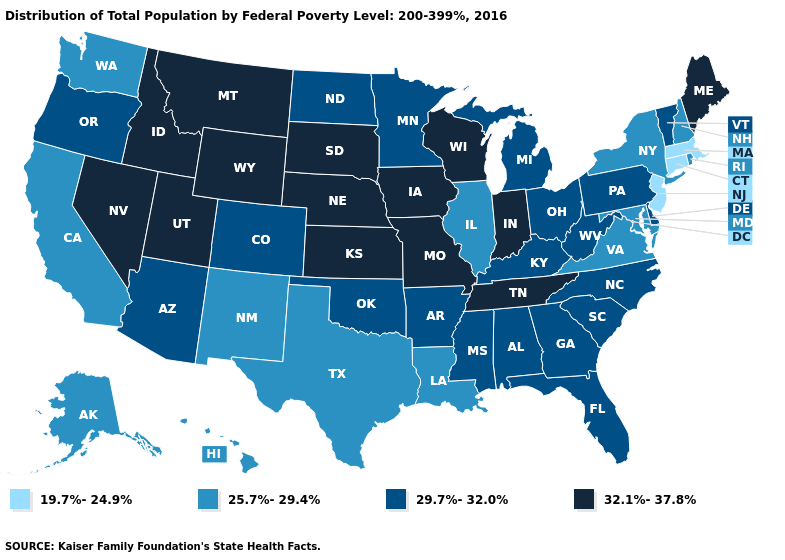Name the states that have a value in the range 29.7%-32.0%?
Be succinct. Alabama, Arizona, Arkansas, Colorado, Delaware, Florida, Georgia, Kentucky, Michigan, Minnesota, Mississippi, North Carolina, North Dakota, Ohio, Oklahoma, Oregon, Pennsylvania, South Carolina, Vermont, West Virginia. What is the value of Louisiana?
Keep it brief. 25.7%-29.4%. Name the states that have a value in the range 32.1%-37.8%?
Answer briefly. Idaho, Indiana, Iowa, Kansas, Maine, Missouri, Montana, Nebraska, Nevada, South Dakota, Tennessee, Utah, Wisconsin, Wyoming. What is the value of Maryland?
Short answer required. 25.7%-29.4%. What is the lowest value in the USA?
Write a very short answer. 19.7%-24.9%. Does Connecticut have the lowest value in the USA?
Write a very short answer. Yes. Which states have the lowest value in the USA?
Answer briefly. Connecticut, Massachusetts, New Jersey. Is the legend a continuous bar?
Answer briefly. No. Name the states that have a value in the range 29.7%-32.0%?
Concise answer only. Alabama, Arizona, Arkansas, Colorado, Delaware, Florida, Georgia, Kentucky, Michigan, Minnesota, Mississippi, North Carolina, North Dakota, Ohio, Oklahoma, Oregon, Pennsylvania, South Carolina, Vermont, West Virginia. Name the states that have a value in the range 32.1%-37.8%?
Be succinct. Idaho, Indiana, Iowa, Kansas, Maine, Missouri, Montana, Nebraska, Nevada, South Dakota, Tennessee, Utah, Wisconsin, Wyoming. Among the states that border South Dakota , which have the highest value?
Concise answer only. Iowa, Montana, Nebraska, Wyoming. Among the states that border Illinois , does Kentucky have the highest value?
Keep it brief. No. Name the states that have a value in the range 29.7%-32.0%?
Keep it brief. Alabama, Arizona, Arkansas, Colorado, Delaware, Florida, Georgia, Kentucky, Michigan, Minnesota, Mississippi, North Carolina, North Dakota, Ohio, Oklahoma, Oregon, Pennsylvania, South Carolina, Vermont, West Virginia. Among the states that border Virginia , which have the lowest value?
Give a very brief answer. Maryland. 